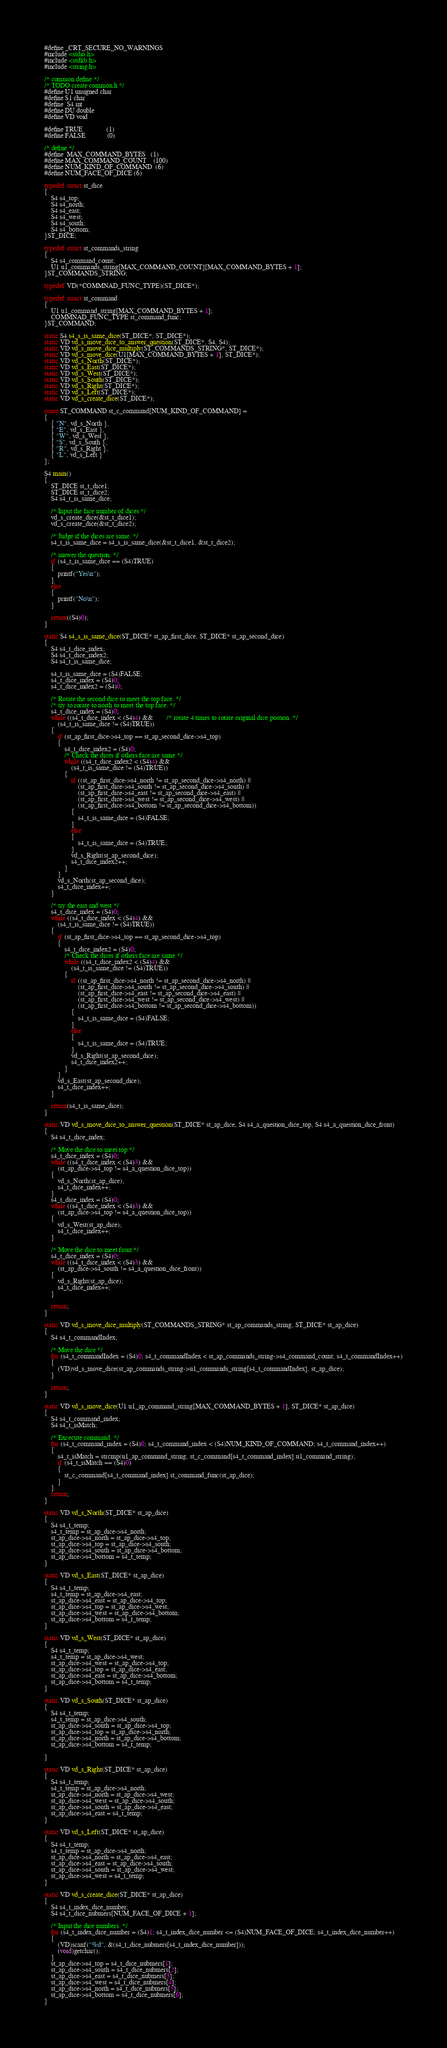<code> <loc_0><loc_0><loc_500><loc_500><_C_>#define _CRT_SECURE_NO_WARNINGS
#include <stdio.h>
#include <stdlib.h>
#include <string.h>

/* common define */
/* TODO create common.h */
#define U1 unsigned char
#define S1 char
#define	S4 int
#define DU double
#define VD void

#define TRUE              (1)
#define FALSE             (0)

/* define */
#define	MAX_COMMAND_BYTES	(1)
#define MAX_COMMAND_COUNT	(100)
#define NUM_KIND_OF_COMMAND	(6)
#define NUM_FACE_OF_DICE	(6)

typedef struct st_dice
{
	S4 s4_top;
	S4 s4_north;
	S4 s4_east;
	S4 s4_west;
	S4 s4_south;
	S4 s4_bottom;
}ST_DICE;

typedef struct st_commands_string
{
	S4 s4_command_count;
	U1 u1_commands_string[MAX_COMMAND_COUNT][MAX_COMMAND_BYTES + 1];
}ST_COMMANDS_STRING;

typedef VD(*COMMNAD_FUNC_TYPE)(ST_DICE*);

typedef struct st_command
{
	U1 u1_command_string[MAX_COMMAND_BYTES + 1];
	COMMNAD_FUNC_TYPE st_command_func;
}ST_COMMAND;

static S4 s4_s_is_same_dice(ST_DICE*, ST_DICE*);
static VD vd_s_move_dice_to_answer_question(ST_DICE*, S4, S4);
static VD vd_s_move_dice_multiply(ST_COMMANDS_STRING*, ST_DICE*);
static VD vd_s_move_dice(U1[MAX_COMMAND_BYTES + 1], ST_DICE*);
static VD vd_s_North(ST_DICE*);
static VD vd_s_East(ST_DICE*);
static VD vd_s_West(ST_DICE*);
static VD vd_s_South(ST_DICE*);
static VD vd_s_Right(ST_DICE*);
static VD vd_s_Left(ST_DICE*);
static VD vd_s_create_dice(ST_DICE*);

const ST_COMMAND st_c_command[NUM_KIND_OF_COMMAND] =
{
	{ "N", vd_s_North },
	{ "E", vd_s_East },
	{ "W", vd_s_West },
	{ "S", vd_s_South },
	{ "R", vd_s_Right },
	{ "L", vd_s_Left }
};

S4 main()
{
	ST_DICE st_t_dice1;
	ST_DICE st_t_dice2;
	S4 s4_t_is_same_dice;

	/* Input the face number of dices */
	vd_s_create_dice(&st_t_dice1);
	vd_s_create_dice(&st_t_dice2);

	/* Judge if the dices are same. */
	s4_t_is_same_dice = s4_s_is_same_dice(&st_t_dice1, &st_t_dice2);

	/* answer the question. */
	if (s4_t_is_same_dice == (S4)TRUE)
	{
		printf("Yes\n");
	}
	else
	{
		printf("No\n");
	}

	return((S4)0);
}

static S4 s4_s_is_same_dice(ST_DICE* st_ap_first_dice, ST_DICE* st_ap_second_dice)
{
	S4 s4_t_dice_index;
	S4 s4_t_dice_index2;
	S4 s4_t_is_same_dice;

	s4_t_is_same_dice = (S4)FALSE;
	s4_t_dice_index = (S4)0;
	s4_t_dice_index2 = (S4)0;

	/* Rotate the second dice to meet the top face. */
	/* try to rorate to north to meet the top face. */
	s4_t_dice_index = (S4)0;
	while ((s4_t_dice_index < (S4)4) &&		/* rotate 4 times to rotate original dice postion. */
		(s4_t_is_same_dice != (S4)TRUE))
	{
		if (st_ap_first_dice->s4_top == st_ap_second_dice->s4_top)
		{
			s4_t_dice_index2 = (S4)0;
			/* Check the dices if others face are same */
			while ((s4_t_dice_index2 < (S4)4) &&
				(s4_t_is_same_dice != (S4)TRUE))
			{
				if ((st_ap_first_dice->s4_north != st_ap_second_dice->s4_north) ||
					(st_ap_first_dice->s4_south != st_ap_second_dice->s4_south) ||
					(st_ap_first_dice->s4_east != st_ap_second_dice->s4_east) ||
					(st_ap_first_dice->s4_west != st_ap_second_dice->s4_west) ||
					(st_ap_first_dice->s4_bottom != st_ap_second_dice->s4_bottom))
				{
					s4_t_is_same_dice = (S4)FALSE;
				}
				else
				{
					s4_t_is_same_dice = (S4)TRUE;
				}
				vd_s_Right(st_ap_second_dice);
				s4_t_dice_index2++;
			}
		}
		vd_s_North(st_ap_second_dice);
		s4_t_dice_index++;
	}

	/* try the east and west */
	s4_t_dice_index = (S4)0;
	while ((s4_t_dice_index < (S4)4) &&
		(s4_t_is_same_dice != (S4)TRUE))
	{
		if (st_ap_first_dice->s4_top == st_ap_second_dice->s4_top)
		{
			s4_t_dice_index2 = (S4)0;
			/* Check the dices if others face are same */
			while ((s4_t_dice_index2 < (S4)4) &&
				(s4_t_is_same_dice != (S4)TRUE))
			{
				if ((st_ap_first_dice->s4_north != st_ap_second_dice->s4_north) ||
					(st_ap_first_dice->s4_south != st_ap_second_dice->s4_south) ||
					(st_ap_first_dice->s4_east != st_ap_second_dice->s4_east) ||
					(st_ap_first_dice->s4_west != st_ap_second_dice->s4_west) ||
					(st_ap_first_dice->s4_bottom != st_ap_second_dice->s4_bottom))
				{
					s4_t_is_same_dice = (S4)FALSE;
				}
				else
				{
					s4_t_is_same_dice = (S4)TRUE;
				}
				vd_s_Right(st_ap_second_dice);
				s4_t_dice_index2++;
			}
		}
		vd_s_East(st_ap_second_dice);
		s4_t_dice_index++;
	}

	return(s4_t_is_same_dice);
}

static VD vd_s_move_dice_to_answer_question(ST_DICE* st_ap_dice, S4 s4_a_question_dice_top, S4 s4_a_question_dice_front)
{
	S4 s4_t_dice_index;

	/* Move the dice to meet top */
	s4_t_dice_index = (S4)0;
	while ((s4_t_dice_index < (S4)3) &&
		(st_ap_dice->s4_top != s4_a_question_dice_top))
	{
		vd_s_North(st_ap_dice);
		s4_t_dice_index++;
	}
	s4_t_dice_index = (S4)0;
	while ((s4_t_dice_index < (S4)3) &&
		(st_ap_dice->s4_top != s4_a_question_dice_top))
	{
		vd_s_West(st_ap_dice);
		s4_t_dice_index++;
	}

	/* Move the dice to meet front */
	s4_t_dice_index = (S4)0;
	while ((s4_t_dice_index < (S4)3) &&
		(st_ap_dice->s4_south != s4_a_question_dice_front))
	{
		vd_s_Right(st_ap_dice);
		s4_t_dice_index++;
	}

	return;
}

static VD vd_s_move_dice_multiply(ST_COMMANDS_STRING* st_ap_commands_string, ST_DICE* st_ap_dice)
{
	S4 s4_t_commandIndex;

	/* Move the dice */
	for (s4_t_commandIndex = (S4)0; s4_t_commandIndex < st_ap_commands_string->s4_command_count; s4_t_commandIndex++)
	{
		(VD)vd_s_move_dice(st_ap_commands_string->u1_commands_string[s4_t_commandIndex], st_ap_dice);
	}

	return;
}

static VD vd_s_move_dice(U1 u1_ap_command_string[MAX_COMMAND_BYTES + 1], ST_DICE* st_ap_dice)
{
	S4 s4_t_command_index;
	S4 s4_t_isMatch;

	/* Excecute command. */
	for (s4_t_command_index = (S4)0; s4_t_command_index < (S4)NUM_KIND_OF_COMMAND; s4_t_command_index++)
	{
		s4_t_isMatch = strcmp(u1_ap_command_string, st_c_command[s4_t_command_index].u1_command_string);
		if (s4_t_isMatch == (S4)0)
		{
			st_c_command[s4_t_command_index].st_command_func(st_ap_dice);
		}
	}
	return;
}

static VD vd_s_North(ST_DICE* st_ap_dice)
{
	S4 s4_t_temp;
	s4_t_temp = st_ap_dice->s4_north;
	st_ap_dice->s4_north = st_ap_dice->s4_top;
	st_ap_dice->s4_top = st_ap_dice->s4_south;
	st_ap_dice->s4_south = st_ap_dice->s4_bottom;
	st_ap_dice->s4_bottom = s4_t_temp;
}

static VD vd_s_East(ST_DICE* st_ap_dice)
{
	S4 s4_t_temp;
	s4_t_temp = st_ap_dice->s4_east;
	st_ap_dice->s4_east = st_ap_dice->s4_top;
	st_ap_dice->s4_top = st_ap_dice->s4_west;
	st_ap_dice->s4_west = st_ap_dice->s4_bottom;
	st_ap_dice->s4_bottom = s4_t_temp;
}

static VD vd_s_West(ST_DICE* st_ap_dice)
{
	S4 s4_t_temp;
	s4_t_temp = st_ap_dice->s4_west;
	st_ap_dice->s4_west = st_ap_dice->s4_top;
	st_ap_dice->s4_top = st_ap_dice->s4_east;
	st_ap_dice->s4_east = st_ap_dice->s4_bottom;
	st_ap_dice->s4_bottom = s4_t_temp;
}

static VD vd_s_South(ST_DICE* st_ap_dice)
{
	S4 s4_t_temp;
	s4_t_temp = st_ap_dice->s4_south;
	st_ap_dice->s4_south = st_ap_dice->s4_top;
	st_ap_dice->s4_top = st_ap_dice->s4_north;
	st_ap_dice->s4_north = st_ap_dice->s4_bottom;
	st_ap_dice->s4_bottom = s4_t_temp;

}

static VD vd_s_Right(ST_DICE* st_ap_dice)
{
	S4 s4_t_temp;
	s4_t_temp = st_ap_dice->s4_north;
	st_ap_dice->s4_north = st_ap_dice->s4_west;
	st_ap_dice->s4_west = st_ap_dice->s4_south;
	st_ap_dice->s4_south = st_ap_dice->s4_east;
	st_ap_dice->s4_east = s4_t_temp;
}

static VD vd_s_Left(ST_DICE* st_ap_dice)
{
	S4 s4_t_temp;
	s4_t_temp = st_ap_dice->s4_north;
	st_ap_dice->s4_north = st_ap_dice->s4_east;
	st_ap_dice->s4_east = st_ap_dice->s4_south;
	st_ap_dice->s4_south = st_ap_dice->s4_west;
	st_ap_dice->s4_west = s4_t_temp;
}

static VD vd_s_create_dice(ST_DICE* st_ap_dice)
{
	S4 s4_t_index_dice_number;
	S4 s4_t_dice_nubmers[NUM_FACE_OF_DICE + 1];

	/* Input the dice numbers. */
	for (s4_t_index_dice_number = (S4)1; s4_t_index_dice_number <= (S4)NUM_FACE_OF_DICE; s4_t_index_dice_number++)
	{
		(VD)scanf("%d", &(s4_t_dice_nubmers[s4_t_index_dice_number]));
		(void)getchar();
	}
	st_ap_dice->s4_top = s4_t_dice_nubmers[1];
	st_ap_dice->s4_south = s4_t_dice_nubmers[2];
	st_ap_dice->s4_east = s4_t_dice_nubmers[3];
	st_ap_dice->s4_west = s4_t_dice_nubmers[4];
	st_ap_dice->s4_north = s4_t_dice_nubmers[5];
	st_ap_dice->s4_bottom = s4_t_dice_nubmers[6];
}

</code> 